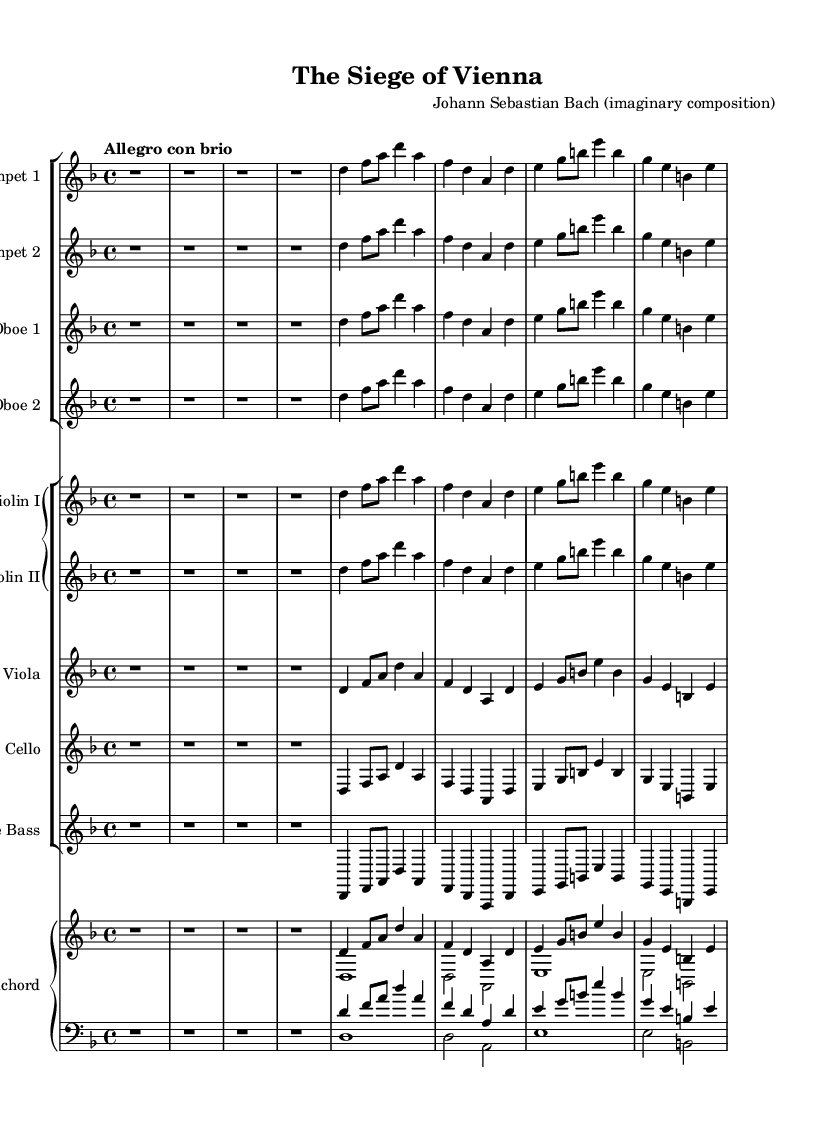What is the key signature of this music? The key signature is indicated at the beginning of the piece and shows two flats (B♭ and E♭) associated with D minor.
Answer: D minor What is the tempo marking of this piece? The tempo marking "Allegro con brio" is notated at the beginning of the score, indicating a fast and lively pace.
Answer: Allegro con brio How many measures are shown in the score? The score has 8 measures, as indicated by the grouping of the music notes and rests present on the staff.
Answer: 8 What type of ensemble is this score written for? The ensemble consists of various instruments typical for a Baroque orchestral piece, including trumpets, oboes, violins, viola, cello, double bass, and harpsichord.
Answer: Baroque orchestra What is the main theme of this orchestral piece suggested by the title? The title "The Siege of Vienna" implies a military theme, suggesting that the music reflects historical battles and military campaigns.
Answer: Military How many trumpet parts are included in this score? The score shows two separate parts for trumpet, a common practice in Baroque compositions to create a fuller sound.
Answer: 2 What is the time signature of this music? The time signature 4/4 is explicitly written at the beginning of the score, indicating four beats per measure with the quarter note receiving one beat.
Answer: 4/4 